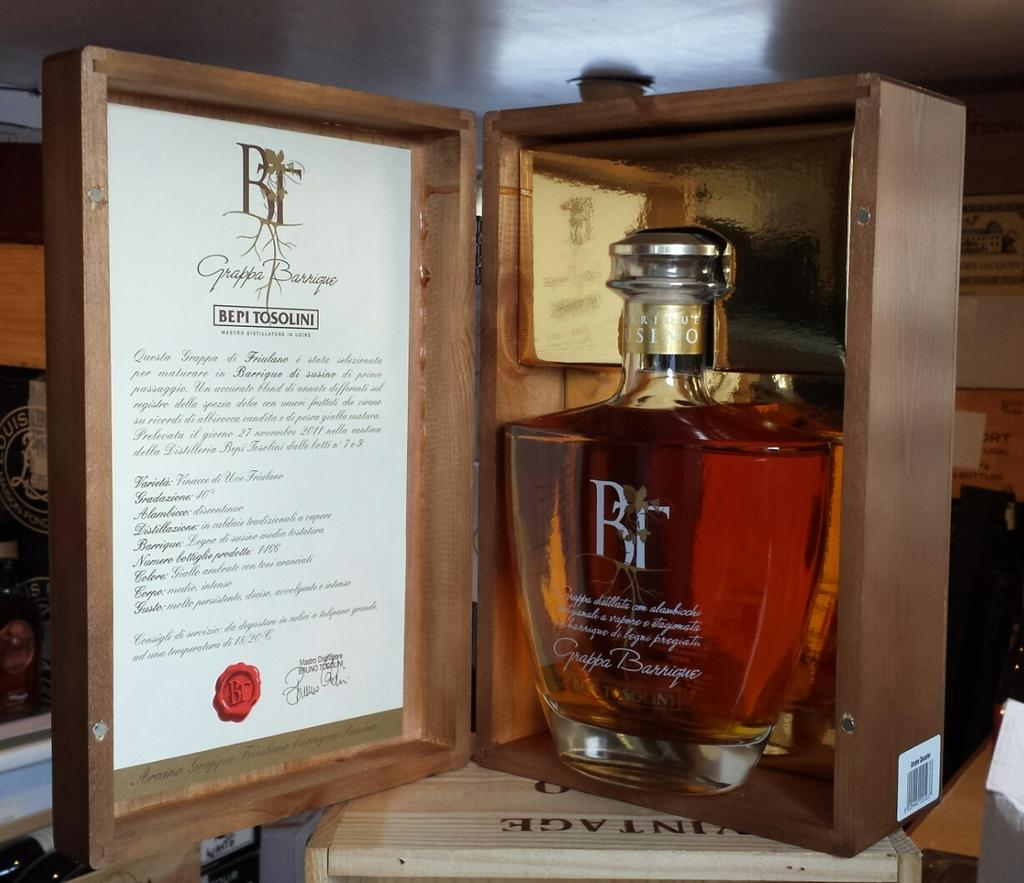<image>
Relay a brief, clear account of the picture shown. A bottle of Bepi Tosolini in a wooden box 